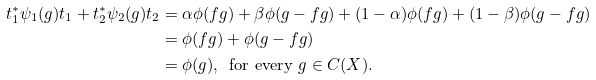<formula> <loc_0><loc_0><loc_500><loc_500>t _ { 1 } ^ { * } \psi _ { 1 } ( g ) t _ { 1 } + t _ { 2 } ^ { * } \psi _ { 2 } ( g ) t _ { 2 } & = \alpha \phi ( f g ) + \beta \phi ( g - f g ) + ( 1 - \alpha ) \phi ( f g ) + ( 1 - \beta ) \phi ( g - f g ) \\ & = \phi ( f g ) + \phi ( g - f g ) \\ & = \phi ( g ) , \, \text { for every } g \in C ( X ) .</formula> 